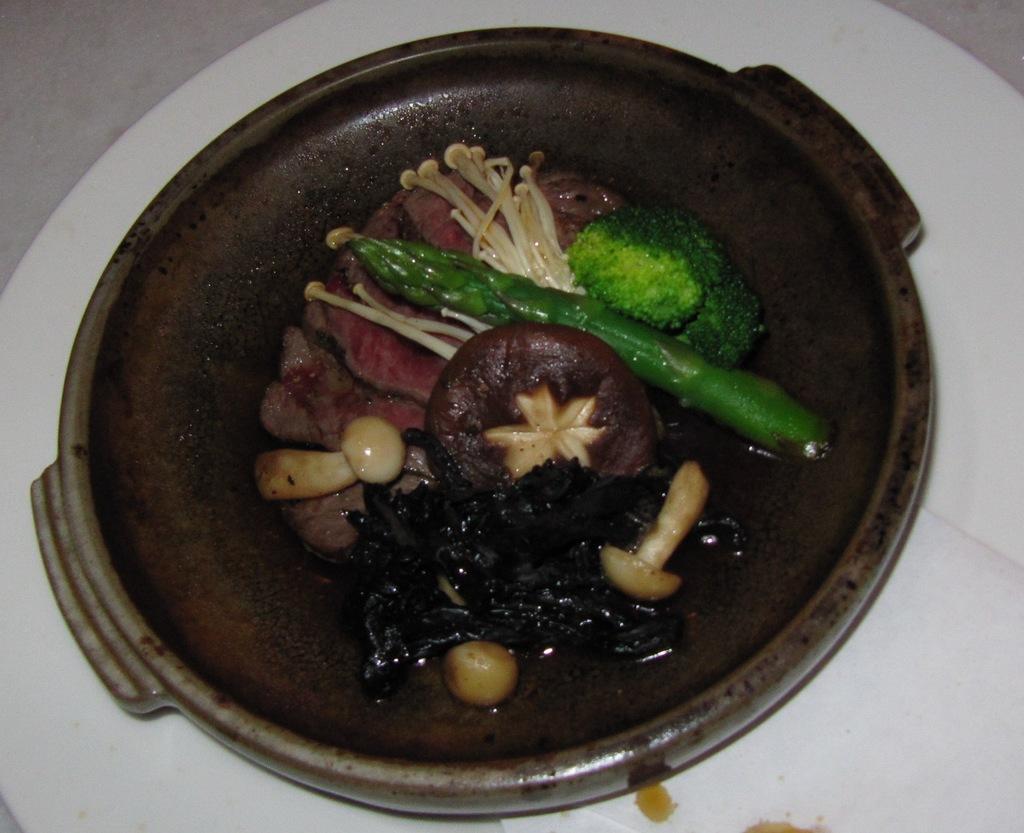How would you summarize this image in a sentence or two? In the image there are cooked mushrooms, vegetables and other food items served in a bowl. 